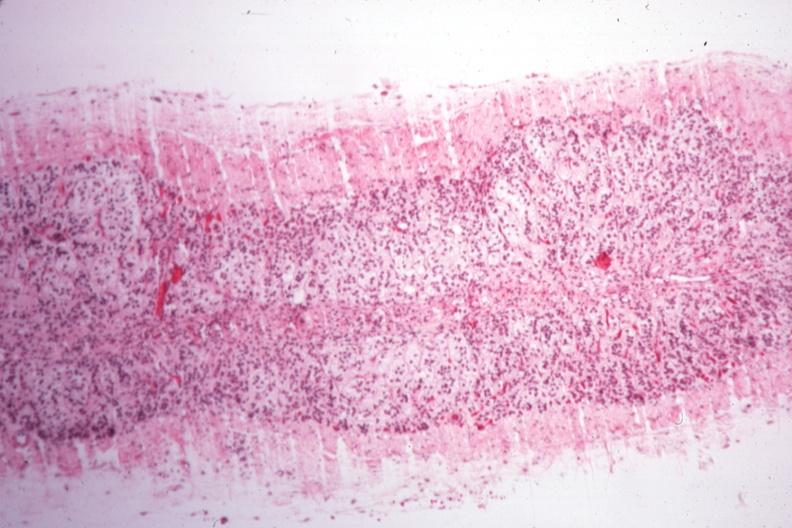what is present?
Answer the question using a single word or phrase. Adrenal 